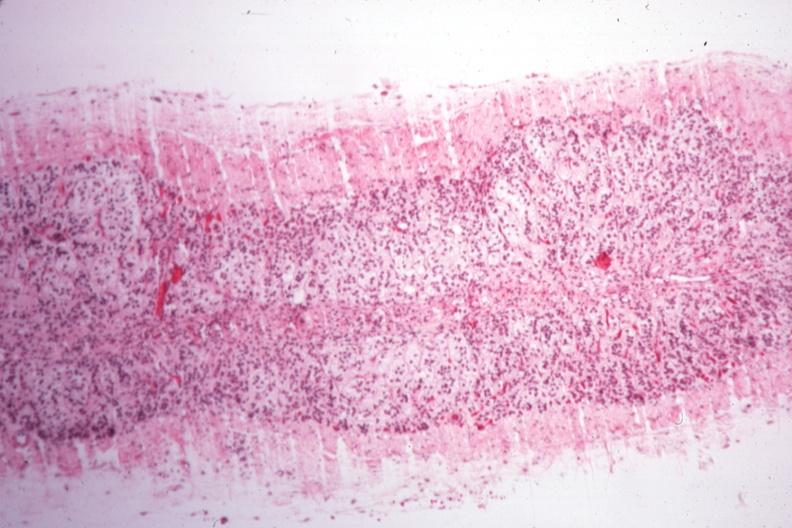what is present?
Answer the question using a single word or phrase. Adrenal 